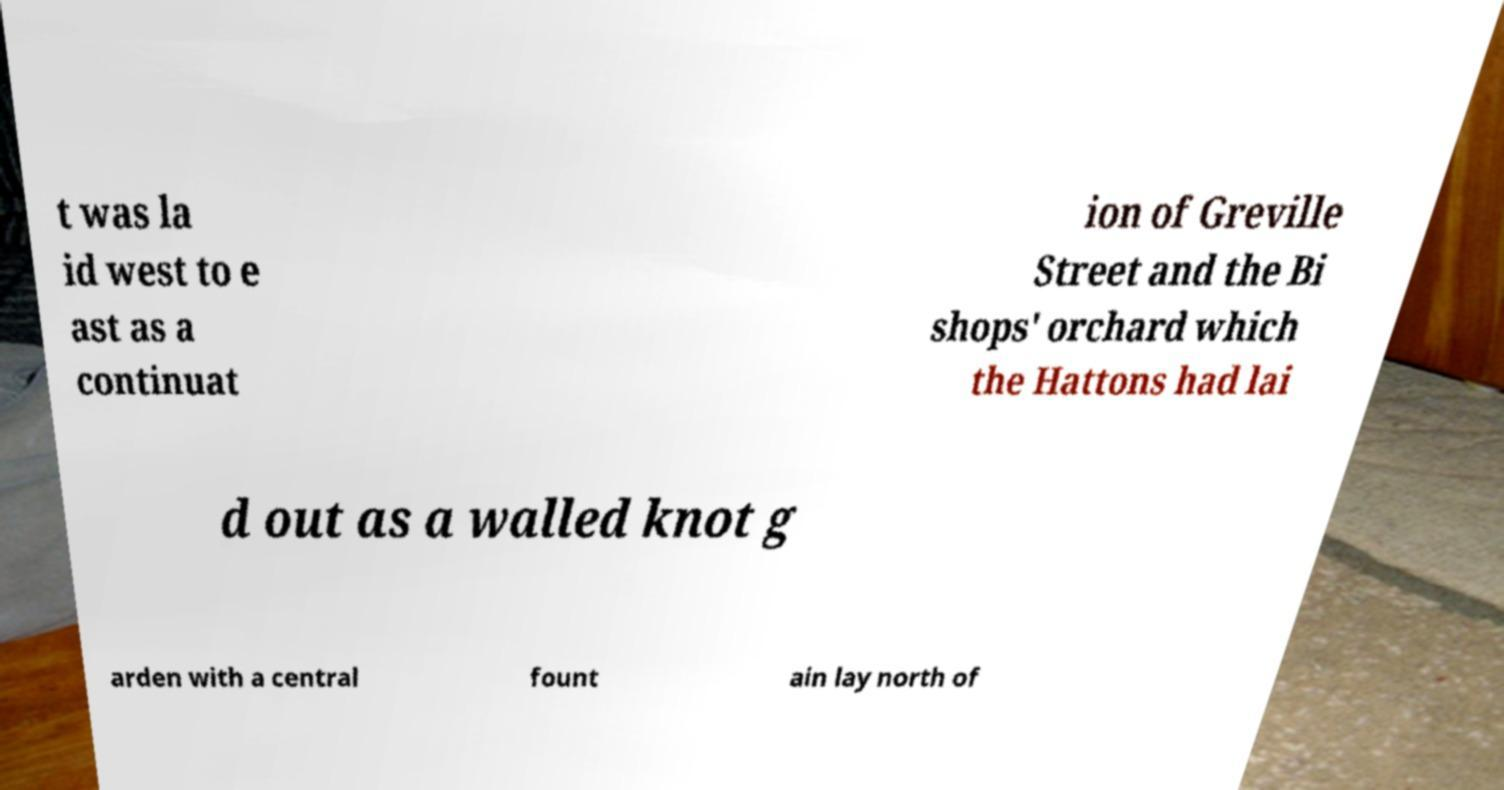Please identify and transcribe the text found in this image. t was la id west to e ast as a continuat ion of Greville Street and the Bi shops' orchard which the Hattons had lai d out as a walled knot g arden with a central fount ain lay north of 